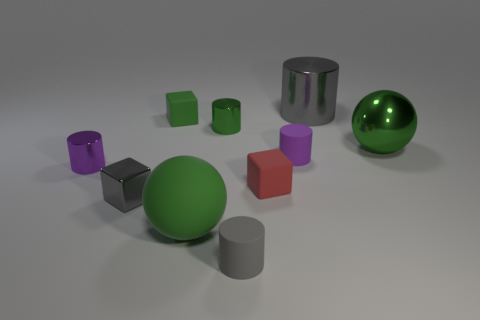Subtract all green cylinders. How many cylinders are left? 4 Subtract all gray metal cylinders. How many cylinders are left? 4 Subtract all yellow cylinders. Subtract all cyan spheres. How many cylinders are left? 5 Subtract all blocks. How many objects are left? 7 Add 9 blue matte cylinders. How many blue matte cylinders exist? 9 Subtract 0 yellow cylinders. How many objects are left? 10 Subtract all big gray cylinders. Subtract all red matte blocks. How many objects are left? 8 Add 5 purple objects. How many purple objects are left? 7 